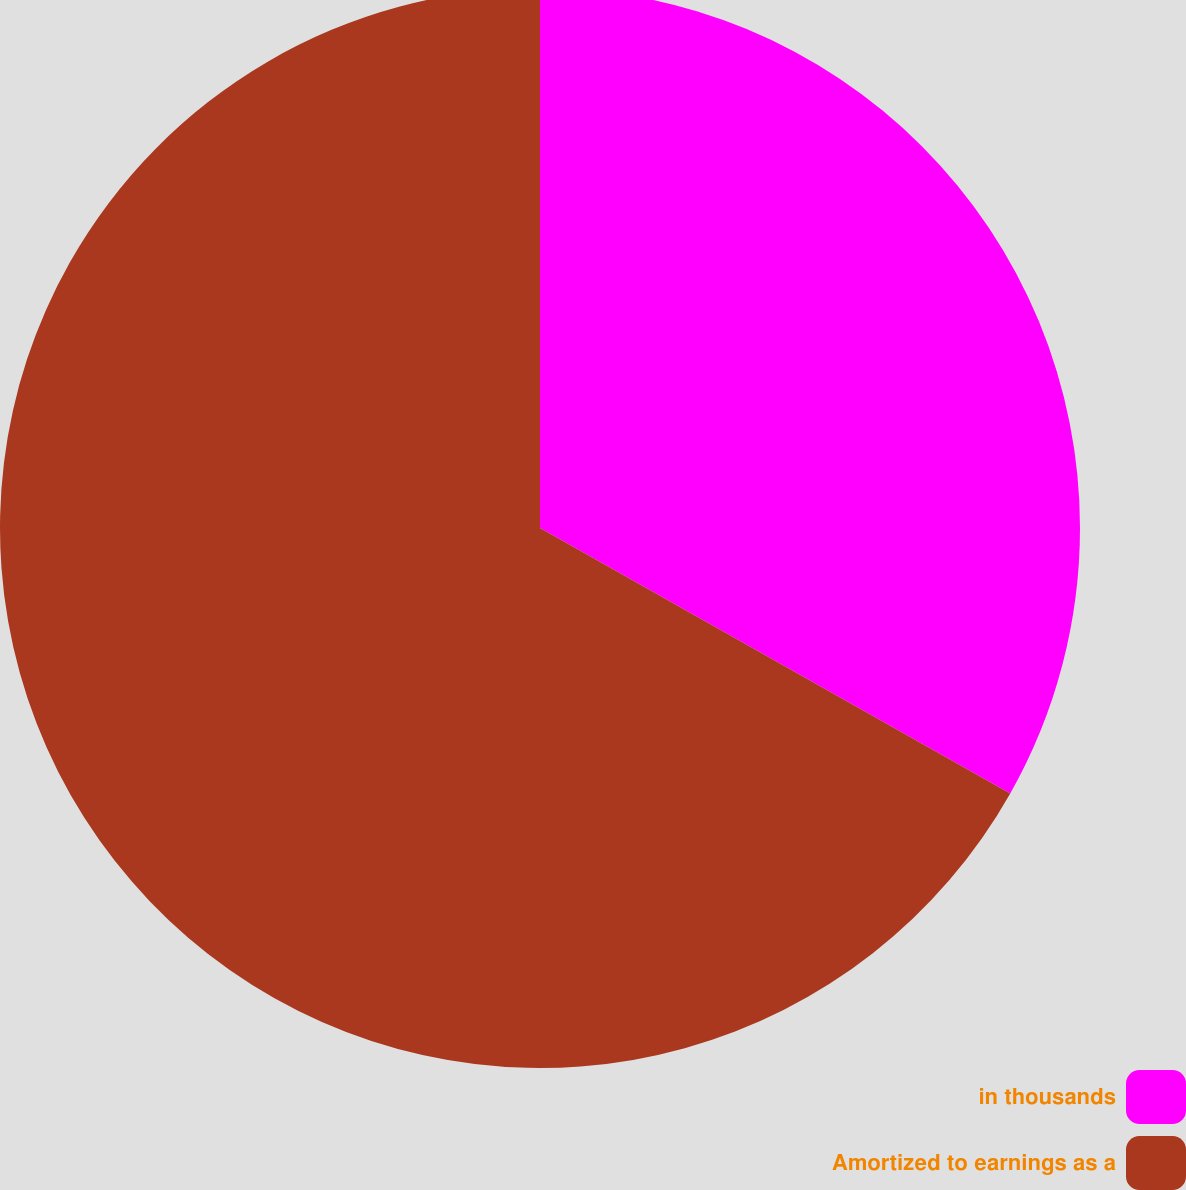Convert chart to OTSL. <chart><loc_0><loc_0><loc_500><loc_500><pie_chart><fcel>in thousands<fcel>Amortized to earnings as a<nl><fcel>33.18%<fcel>66.82%<nl></chart> 